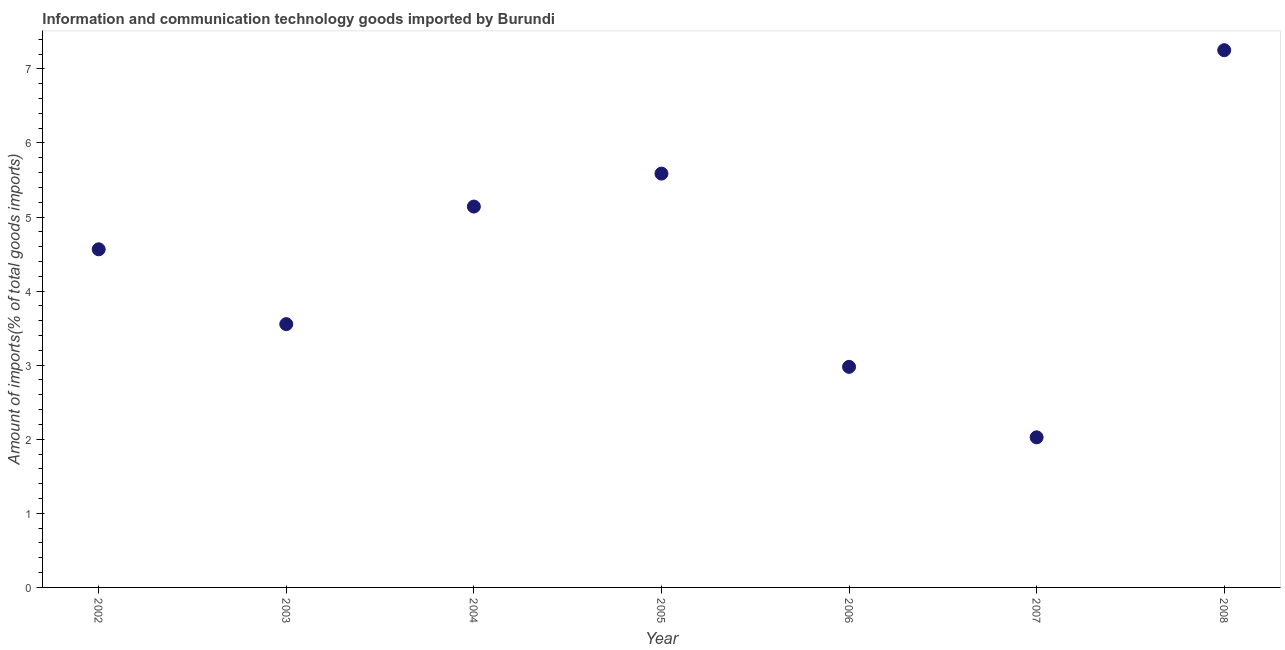What is the amount of ict goods imports in 2004?
Your answer should be compact. 5.14. Across all years, what is the maximum amount of ict goods imports?
Give a very brief answer. 7.25. Across all years, what is the minimum amount of ict goods imports?
Keep it short and to the point. 2.03. In which year was the amount of ict goods imports maximum?
Give a very brief answer. 2008. What is the sum of the amount of ict goods imports?
Provide a succinct answer. 31.1. What is the difference between the amount of ict goods imports in 2002 and 2004?
Make the answer very short. -0.58. What is the average amount of ict goods imports per year?
Your answer should be very brief. 4.44. What is the median amount of ict goods imports?
Make the answer very short. 4.56. In how many years, is the amount of ict goods imports greater than 1.4 %?
Provide a succinct answer. 7. What is the ratio of the amount of ict goods imports in 2005 to that in 2008?
Provide a short and direct response. 0.77. Is the amount of ict goods imports in 2002 less than that in 2006?
Your answer should be very brief. No. What is the difference between the highest and the second highest amount of ict goods imports?
Provide a short and direct response. 1.67. What is the difference between the highest and the lowest amount of ict goods imports?
Offer a terse response. 5.23. In how many years, is the amount of ict goods imports greater than the average amount of ict goods imports taken over all years?
Offer a terse response. 4. Does the amount of ict goods imports monotonically increase over the years?
Offer a very short reply. No. How many dotlines are there?
Ensure brevity in your answer.  1. How many years are there in the graph?
Ensure brevity in your answer.  7. What is the difference between two consecutive major ticks on the Y-axis?
Provide a short and direct response. 1. What is the title of the graph?
Keep it short and to the point. Information and communication technology goods imported by Burundi. What is the label or title of the X-axis?
Keep it short and to the point. Year. What is the label or title of the Y-axis?
Offer a very short reply. Amount of imports(% of total goods imports). What is the Amount of imports(% of total goods imports) in 2002?
Your response must be concise. 4.56. What is the Amount of imports(% of total goods imports) in 2003?
Your answer should be very brief. 3.55. What is the Amount of imports(% of total goods imports) in 2004?
Your response must be concise. 5.14. What is the Amount of imports(% of total goods imports) in 2005?
Keep it short and to the point. 5.59. What is the Amount of imports(% of total goods imports) in 2006?
Keep it short and to the point. 2.98. What is the Amount of imports(% of total goods imports) in 2007?
Provide a short and direct response. 2.03. What is the Amount of imports(% of total goods imports) in 2008?
Provide a succinct answer. 7.25. What is the difference between the Amount of imports(% of total goods imports) in 2002 and 2004?
Provide a short and direct response. -0.58. What is the difference between the Amount of imports(% of total goods imports) in 2002 and 2005?
Your answer should be very brief. -1.02. What is the difference between the Amount of imports(% of total goods imports) in 2002 and 2006?
Provide a succinct answer. 1.59. What is the difference between the Amount of imports(% of total goods imports) in 2002 and 2007?
Your response must be concise. 2.54. What is the difference between the Amount of imports(% of total goods imports) in 2002 and 2008?
Provide a succinct answer. -2.69. What is the difference between the Amount of imports(% of total goods imports) in 2003 and 2004?
Provide a short and direct response. -1.59. What is the difference between the Amount of imports(% of total goods imports) in 2003 and 2005?
Offer a terse response. -2.03. What is the difference between the Amount of imports(% of total goods imports) in 2003 and 2006?
Your response must be concise. 0.58. What is the difference between the Amount of imports(% of total goods imports) in 2003 and 2007?
Provide a succinct answer. 1.53. What is the difference between the Amount of imports(% of total goods imports) in 2003 and 2008?
Provide a short and direct response. -3.7. What is the difference between the Amount of imports(% of total goods imports) in 2004 and 2005?
Ensure brevity in your answer.  -0.44. What is the difference between the Amount of imports(% of total goods imports) in 2004 and 2006?
Provide a short and direct response. 2.16. What is the difference between the Amount of imports(% of total goods imports) in 2004 and 2007?
Make the answer very short. 3.11. What is the difference between the Amount of imports(% of total goods imports) in 2004 and 2008?
Give a very brief answer. -2.11. What is the difference between the Amount of imports(% of total goods imports) in 2005 and 2006?
Provide a succinct answer. 2.61. What is the difference between the Amount of imports(% of total goods imports) in 2005 and 2007?
Offer a terse response. 3.56. What is the difference between the Amount of imports(% of total goods imports) in 2005 and 2008?
Your answer should be very brief. -1.67. What is the difference between the Amount of imports(% of total goods imports) in 2006 and 2007?
Give a very brief answer. 0.95. What is the difference between the Amount of imports(% of total goods imports) in 2006 and 2008?
Keep it short and to the point. -4.27. What is the difference between the Amount of imports(% of total goods imports) in 2007 and 2008?
Your answer should be compact. -5.23. What is the ratio of the Amount of imports(% of total goods imports) in 2002 to that in 2003?
Make the answer very short. 1.28. What is the ratio of the Amount of imports(% of total goods imports) in 2002 to that in 2004?
Give a very brief answer. 0.89. What is the ratio of the Amount of imports(% of total goods imports) in 2002 to that in 2005?
Provide a succinct answer. 0.82. What is the ratio of the Amount of imports(% of total goods imports) in 2002 to that in 2006?
Your answer should be compact. 1.53. What is the ratio of the Amount of imports(% of total goods imports) in 2002 to that in 2007?
Make the answer very short. 2.25. What is the ratio of the Amount of imports(% of total goods imports) in 2002 to that in 2008?
Ensure brevity in your answer.  0.63. What is the ratio of the Amount of imports(% of total goods imports) in 2003 to that in 2004?
Provide a short and direct response. 0.69. What is the ratio of the Amount of imports(% of total goods imports) in 2003 to that in 2005?
Your response must be concise. 0.64. What is the ratio of the Amount of imports(% of total goods imports) in 2003 to that in 2006?
Give a very brief answer. 1.19. What is the ratio of the Amount of imports(% of total goods imports) in 2003 to that in 2007?
Make the answer very short. 1.75. What is the ratio of the Amount of imports(% of total goods imports) in 2003 to that in 2008?
Your answer should be very brief. 0.49. What is the ratio of the Amount of imports(% of total goods imports) in 2004 to that in 2005?
Give a very brief answer. 0.92. What is the ratio of the Amount of imports(% of total goods imports) in 2004 to that in 2006?
Give a very brief answer. 1.73. What is the ratio of the Amount of imports(% of total goods imports) in 2004 to that in 2007?
Your response must be concise. 2.54. What is the ratio of the Amount of imports(% of total goods imports) in 2004 to that in 2008?
Offer a very short reply. 0.71. What is the ratio of the Amount of imports(% of total goods imports) in 2005 to that in 2006?
Your answer should be compact. 1.88. What is the ratio of the Amount of imports(% of total goods imports) in 2005 to that in 2007?
Offer a very short reply. 2.76. What is the ratio of the Amount of imports(% of total goods imports) in 2005 to that in 2008?
Provide a short and direct response. 0.77. What is the ratio of the Amount of imports(% of total goods imports) in 2006 to that in 2007?
Keep it short and to the point. 1.47. What is the ratio of the Amount of imports(% of total goods imports) in 2006 to that in 2008?
Make the answer very short. 0.41. What is the ratio of the Amount of imports(% of total goods imports) in 2007 to that in 2008?
Ensure brevity in your answer.  0.28. 